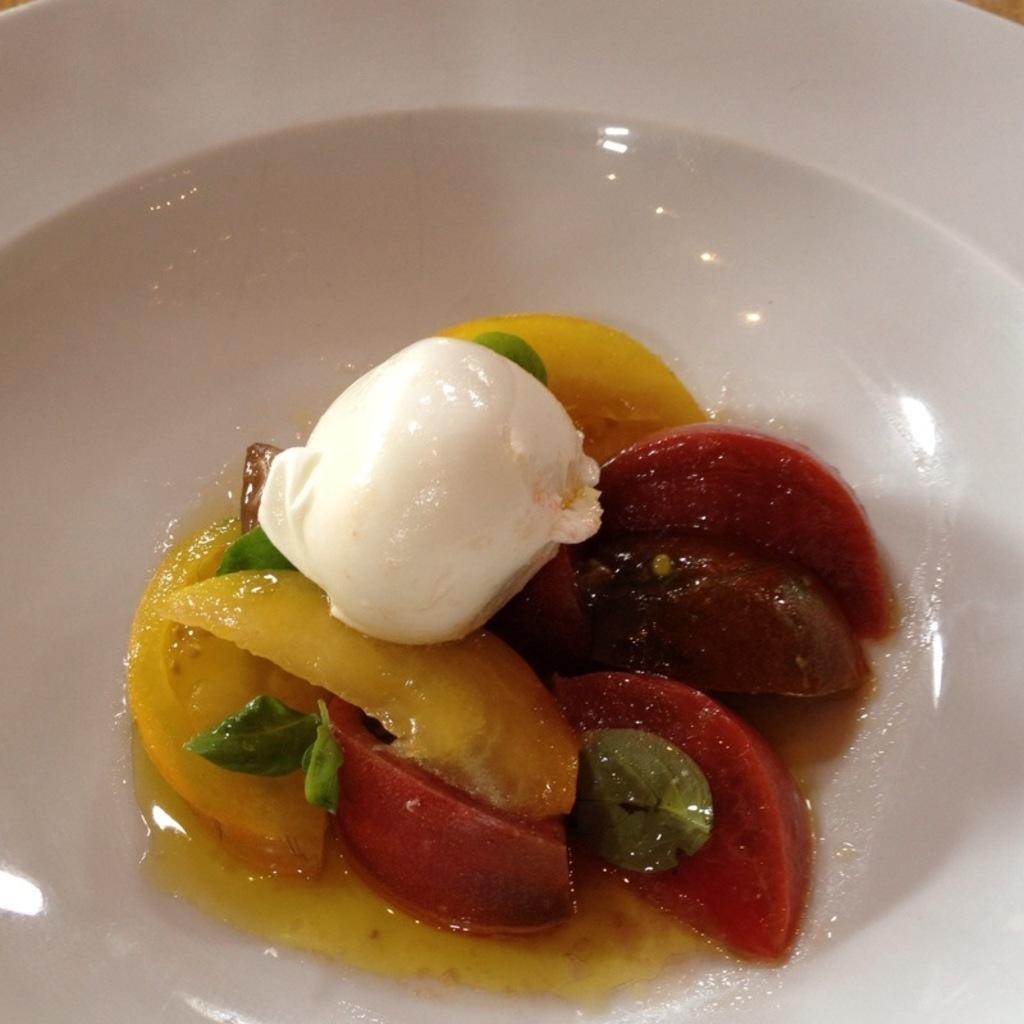What object is present in the picture? There is a bowl in the picture. What is the color of the bowl? The bowl is white in color. What is inside the bowl? There are fruit slices and an ice cream in the bowl. What type of road can be seen in the background of the image? There is no road visible in the image; it only features a bowl with fruit slices and an ice cream. What flavor is the ice cream in the bowl? The flavor of the ice cream is not mentioned in the image, so it cannot be determined. 